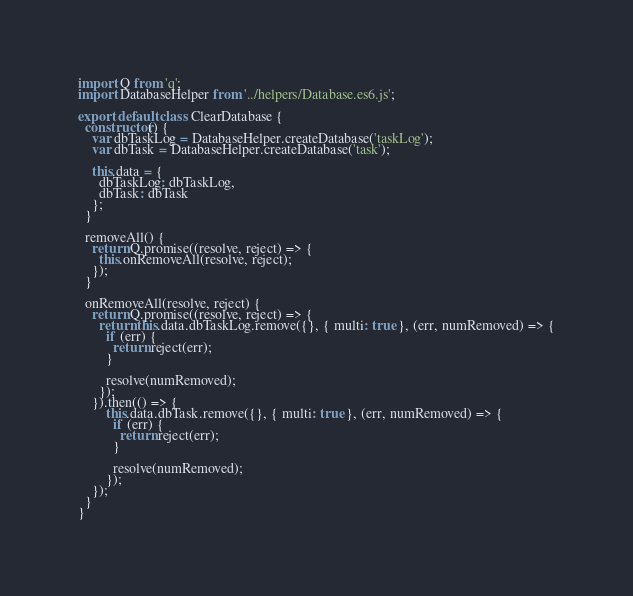<code> <loc_0><loc_0><loc_500><loc_500><_JavaScript_>import Q from 'q';
import DatabaseHelper from '../helpers/Database.es6.js';

export default class ClearDatabase {
  constructor() {
    var dbTaskLog = DatabaseHelper.createDatabase('taskLog');
    var dbTask = DatabaseHelper.createDatabase('task');
    
    this.data = {
      dbTaskLog: dbTaskLog,
      dbTask: dbTask
    };
  }

  removeAll() {
    return Q.promise((resolve, reject) => {
      this.onRemoveAll(resolve, reject);
    });
  }

  onRemoveAll(resolve, reject) {
    return Q.promise((resolve, reject) => {
      return this.data.dbTaskLog.remove({}, { multi: true }, (err, numRemoved) => {
        if (err) {
          return reject(err);
        }

        resolve(numRemoved);
      });
    }).then(() => {
        this.data.dbTask.remove({}, { multi: true }, (err, numRemoved) => {
          if (err) {
            return reject(err);
          }

          resolve(numRemoved);
        });
    });
  }
}</code> 